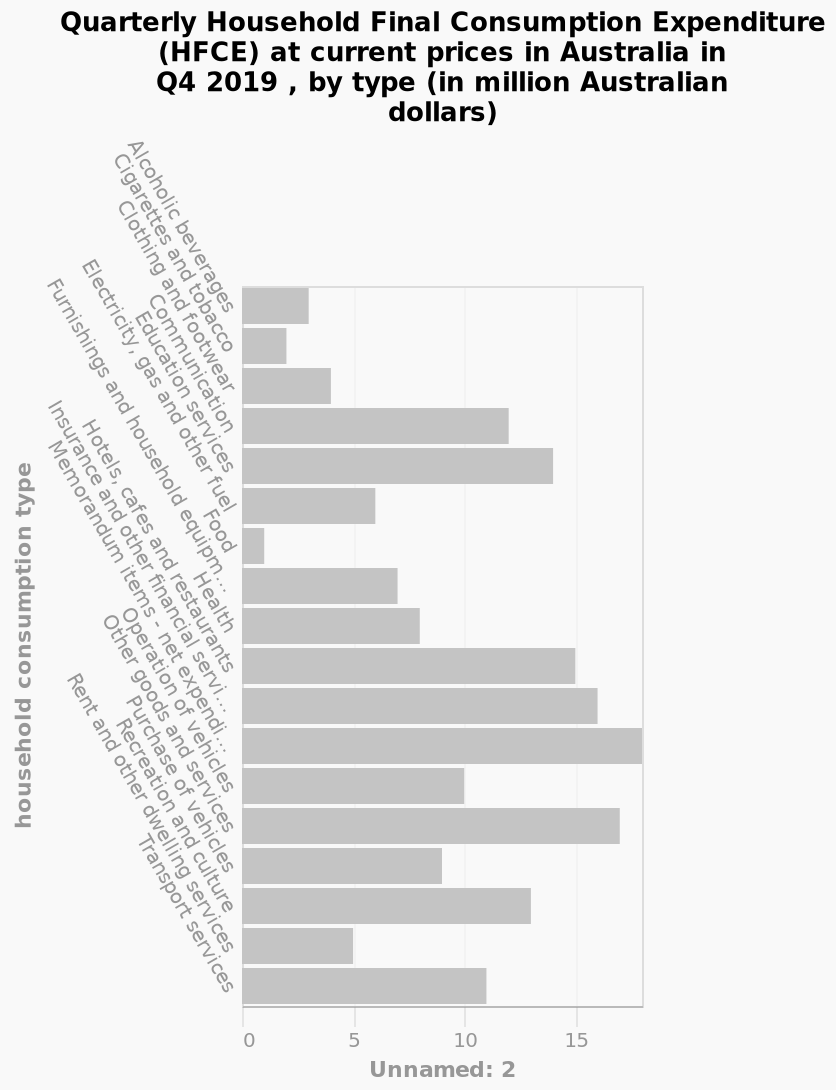<image>
What does the x-axis represent in the bar plot?  The x-axis represents Unnamed: 2. Which category has the highest cost for consumption in the Quarterly Household Final Consumption Expenditure? Memorandum items category has the highest cost for consumption. What is the overall subject of the bar plot? The bar plot presents the Quarterly Household Final Consumption Expenditure (HFCE) at current prices in Australia. According to the figure, what are the lowest and highest costs for consumption in the Quarterly Household Final Consumption Expenditure? Food has the lowest cost for consumption, while memorandum items have the highest cost for consumption. 